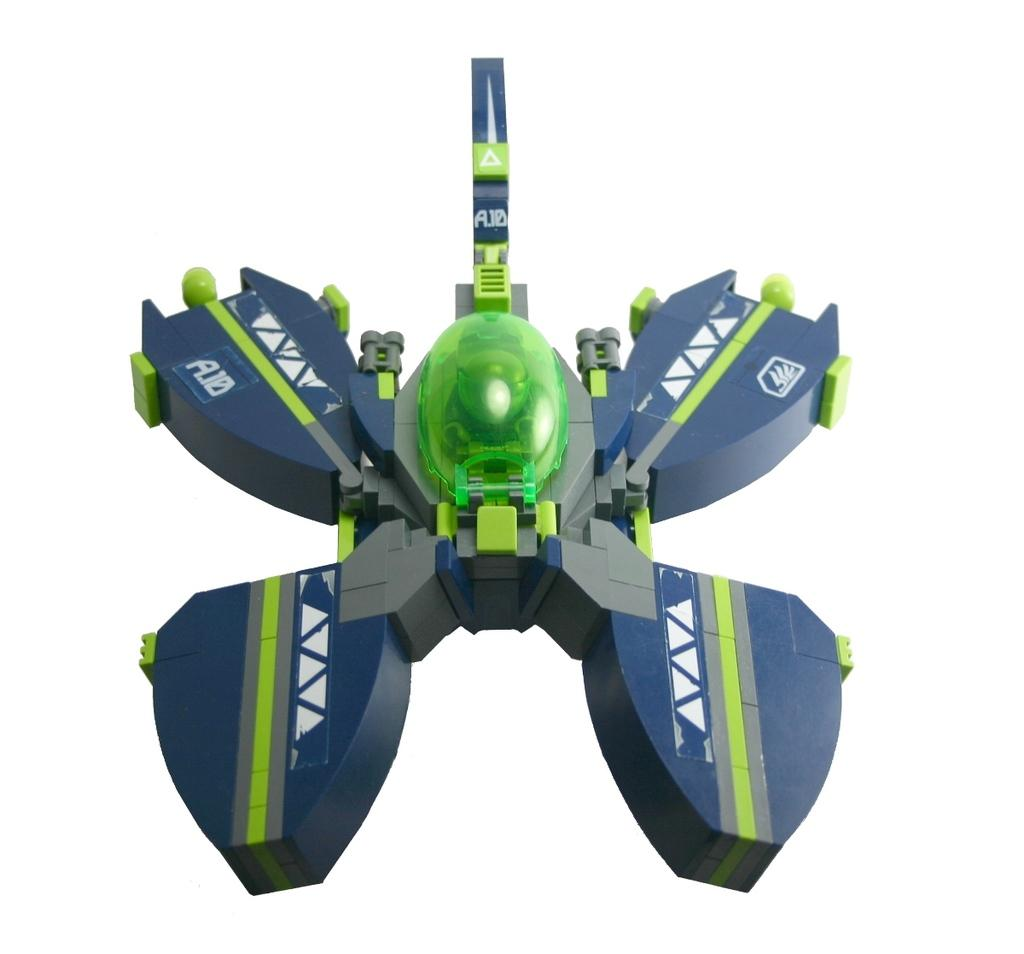What is located in the foreground of the image? There is a toy in the foreground of the image. What color is the background of the image? The background of the image is white. What type of prison is depicted in the image? There is no prison present in the image; it features a toy in the foreground and a white background. What type of conversation is happening between the toy and the background? There is no conversation happening between the toy and the background in the image. 